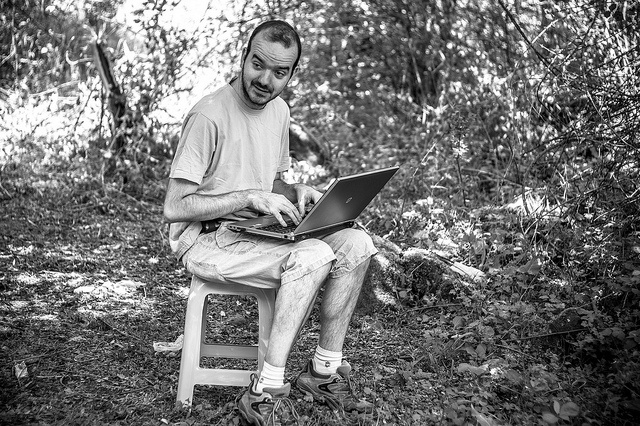Describe the objects in this image and their specific colors. I can see people in black, lightgray, darkgray, and gray tones, chair in black, gray, lightgray, and darkgray tones, and laptop in black, gray, darkgray, and lightgray tones in this image. 